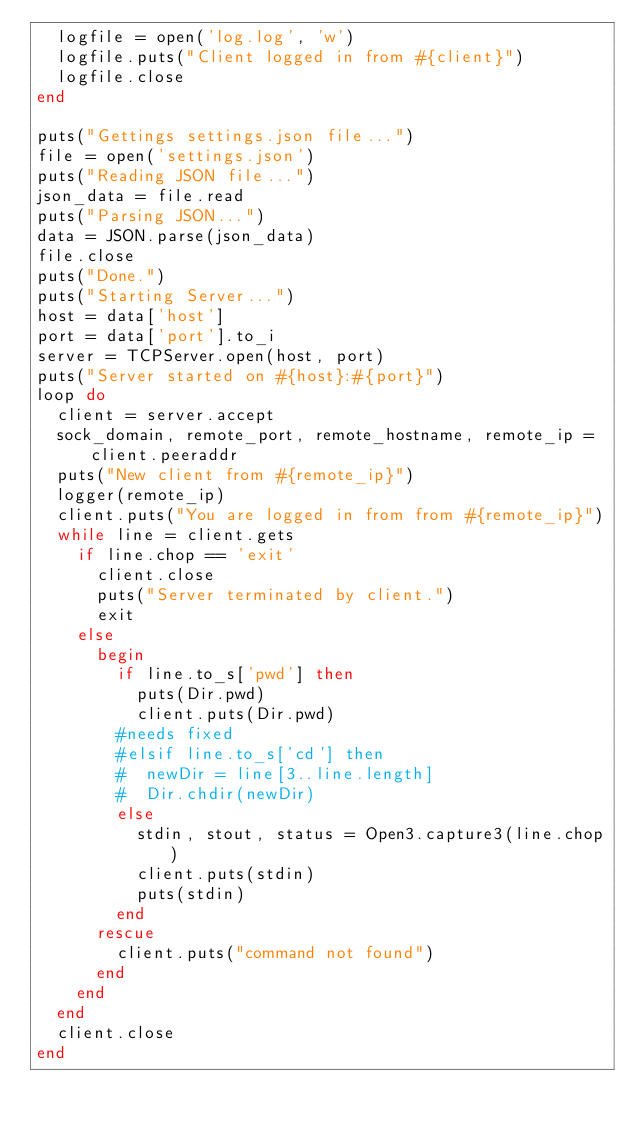Convert code to text. <code><loc_0><loc_0><loc_500><loc_500><_Ruby_>  logfile = open('log.log', 'w')
  logfile.puts("Client logged in from #{client}")
  logfile.close
end

puts("Gettings settings.json file...")
file = open('settings.json')
puts("Reading JSON file...")
json_data = file.read
puts("Parsing JSON...")
data = JSON.parse(json_data)
file.close
puts("Done.")
puts("Starting Server...")
host = data['host']
port = data['port'].to_i
server = TCPServer.open(host, port)
puts("Server started on #{host}:#{port}")
loop do
  client = server.accept
  sock_domain, remote_port, remote_hostname, remote_ip = client.peeraddr
  puts("New client from #{remote_ip}")
  logger(remote_ip)
  client.puts("You are logged in from from #{remote_ip}")
  while line = client.gets
    if line.chop == 'exit'
      client.close
      puts("Server terminated by client.")
      exit
    else
      begin
        if line.to_s['pwd'] then
          puts(Dir.pwd)
          client.puts(Dir.pwd)
        #needs fixed
        #elsif line.to_s['cd'] then
        #  newDir = line[3..line.length]
        #  Dir.chdir(newDir)
        else
          stdin, stout, status = Open3.capture3(line.chop)
          client.puts(stdin)
          puts(stdin)
        end
      rescue
        client.puts("command not found")
      end
    end
  end
  client.close
end
</code> 